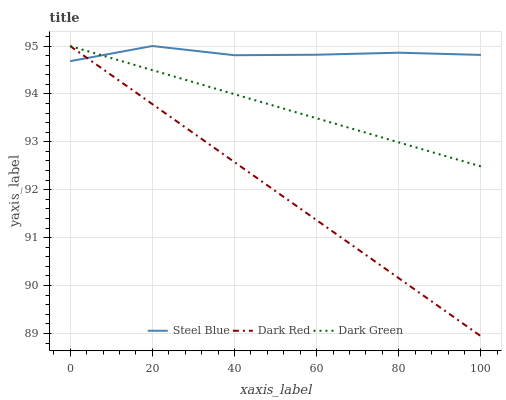Does Dark Green have the minimum area under the curve?
Answer yes or no. No. Does Dark Green have the maximum area under the curve?
Answer yes or no. No. Is Steel Blue the smoothest?
Answer yes or no. No. Is Dark Green the roughest?
Answer yes or no. No. Does Dark Green have the lowest value?
Answer yes or no. No. 